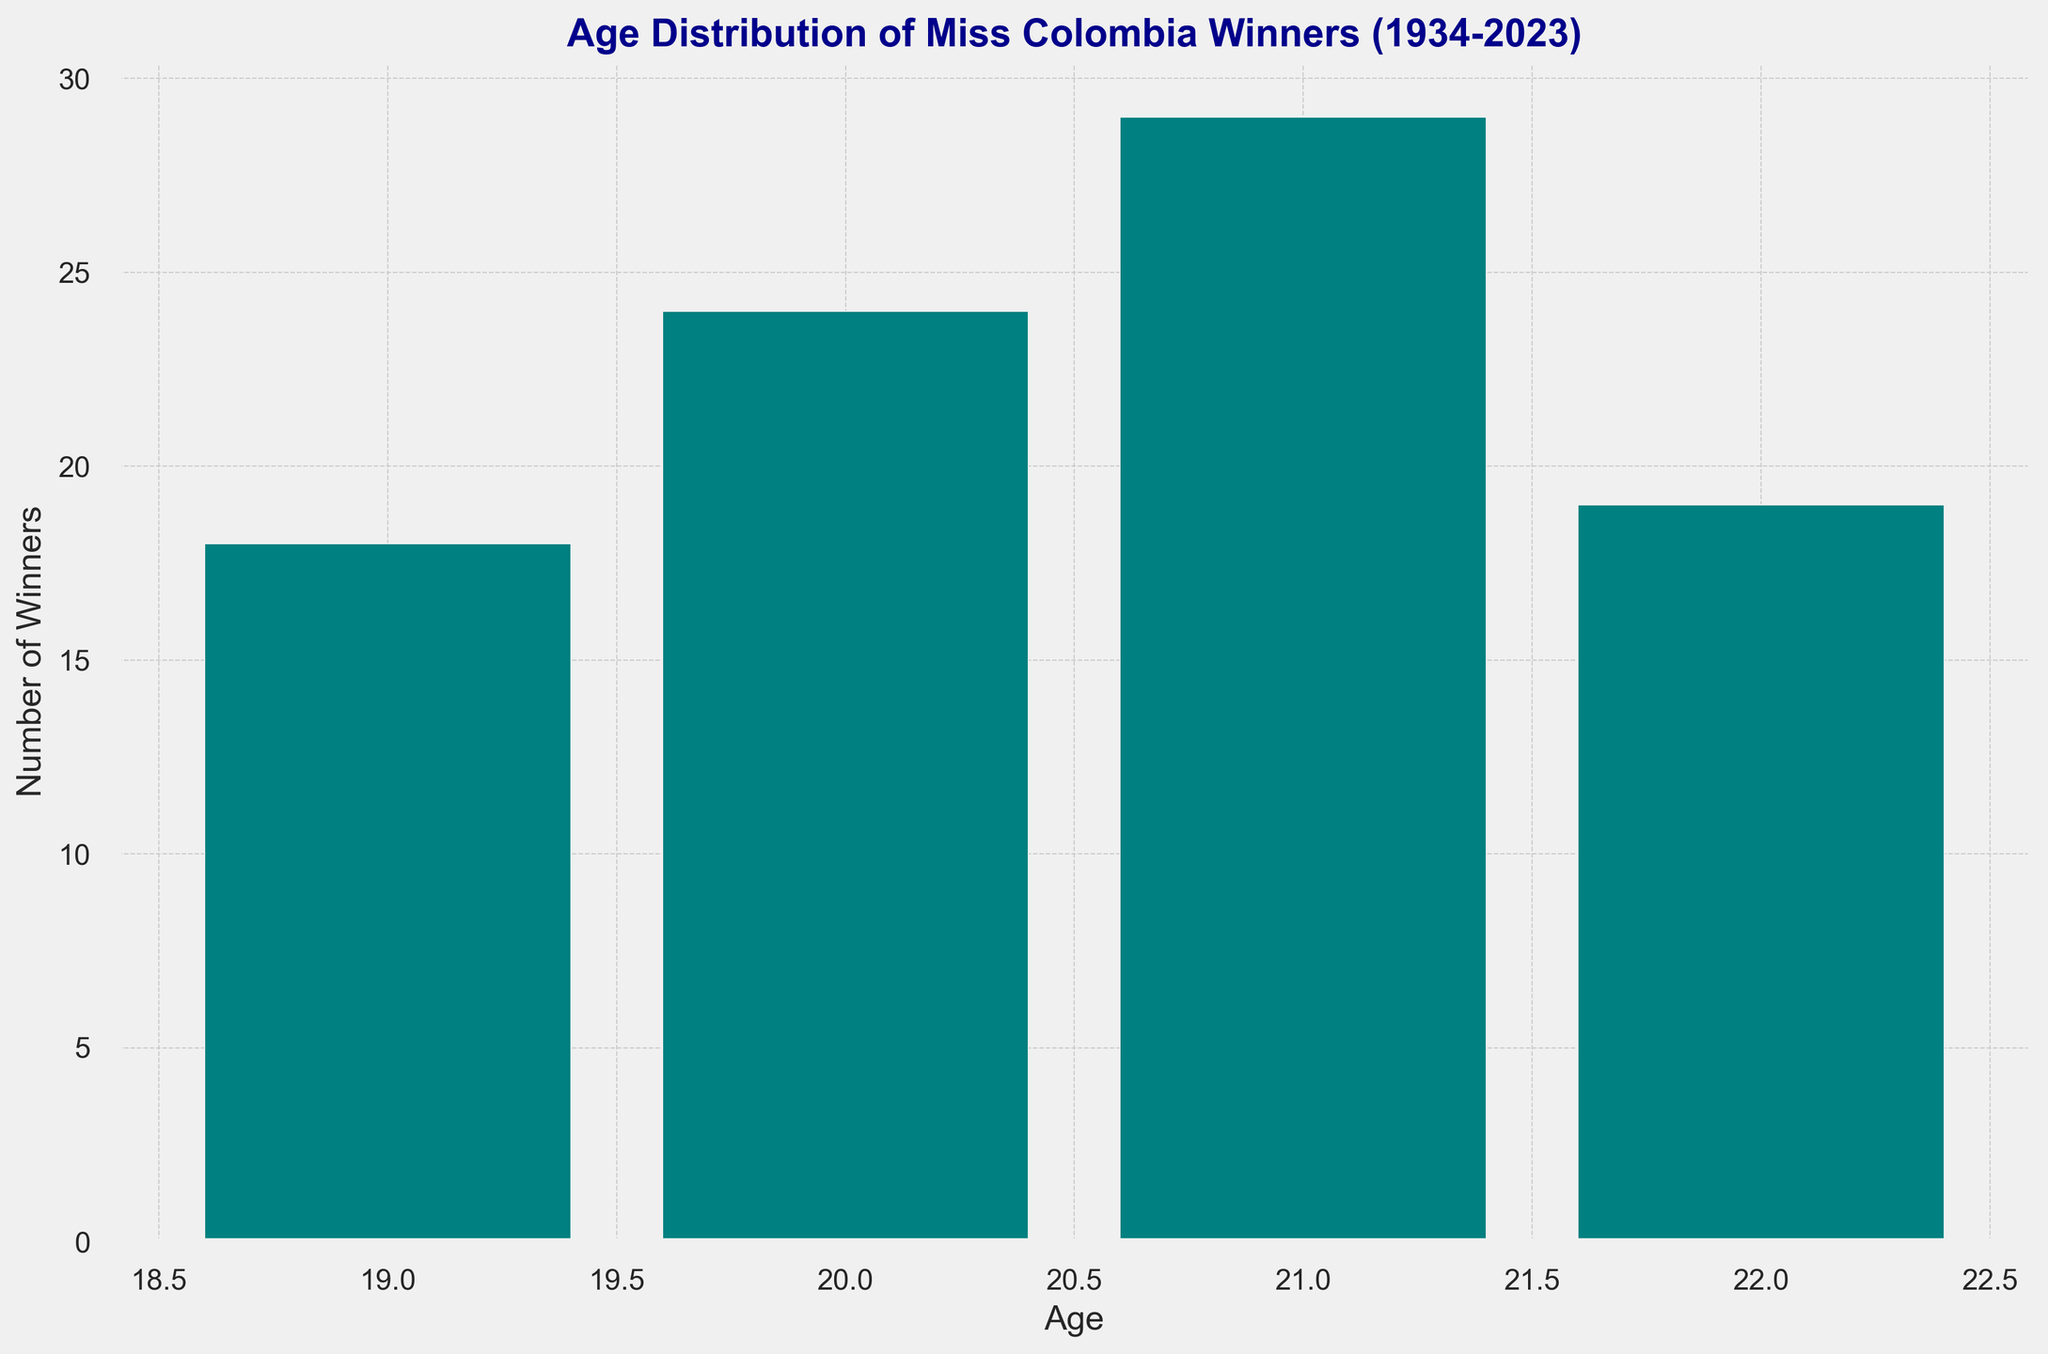What is the most common age among Miss Colombia winners? By looking at the heights of the bars, identify the tallest bar which represents the most common age with the highest number of winners.
Answer: 21 How many Miss Colombia winners were aged 22? Count the total number of winners by identifying the height of the bar corresponding to age 22.
Answer: 17 Are there more winners aged 19 or 20? Compare the height of the bars representing ages 19 and 20. The bar with the greater height represents the age with more winners.
Answer: 20 What is the total number of winners aged 20 and 21? Add the heights of the bars representing ages 20 and 21.
Answer: 32 Which age has fewer winners, 19 or 21? Compare the heights of the bars for ages 19 and 21. The bar with the lower height represents the age with fewer winners.
Answer: 19 Is the distribution of winners' ages more skewed towards younger or older ages? Observe the distribution of the bar heights. If more winners are toward the left (younger ages), it is skewed towards younger ages. If more winners are towards the right (older ages), it is skewed towards older ages.
Answer: Younger How many ages have a winner count less than 10? Count the number of bars which heights are below the 10 mark.
Answer: 2 What is the difference in the number of winners between the age groups 20-21 and 22? Calculate the total number of winners aged 20 and 21, then subtract the number of winners aged 22 from it.
Answer: 15 Is the number of winners aged 22 more than 21? Compare the heights of the bars for ages 22 and 21.
Answer: No What is the average age of Miss Colombia winners in the given distribution? Calculate the weighted average by summing the products of each age and its frequency, then divide by the total number of winners.
Answer: 20.67 